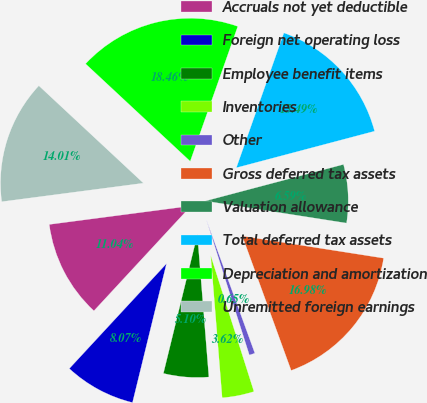Convert chart. <chart><loc_0><loc_0><loc_500><loc_500><pie_chart><fcel>Accruals not yet deductible<fcel>Foreign net operating loss<fcel>Employee benefit items<fcel>Inventories<fcel>Other<fcel>Gross deferred tax assets<fcel>Valuation allowance<fcel>Total deferred tax assets<fcel>Depreciation and amortization<fcel>Unremitted foreign earnings<nl><fcel>11.04%<fcel>8.07%<fcel>5.1%<fcel>3.62%<fcel>0.65%<fcel>16.98%<fcel>6.59%<fcel>15.49%<fcel>18.46%<fcel>14.01%<nl></chart> 